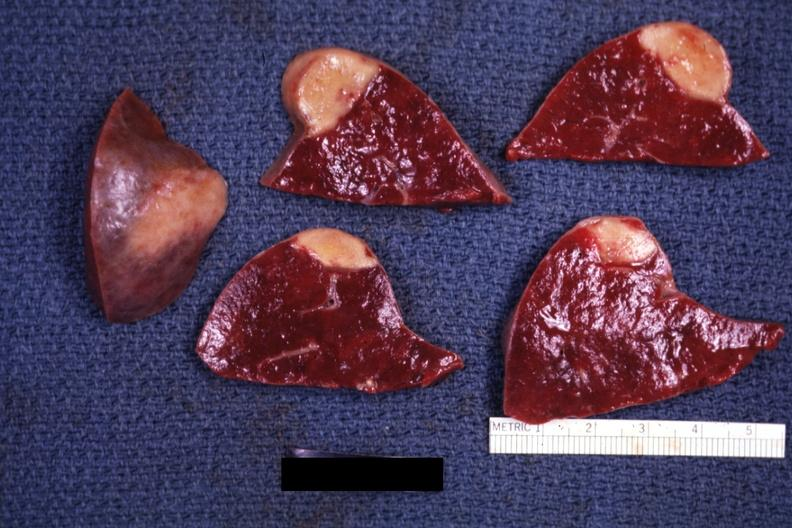what is present?
Answer the question using a single word or phrase. Hematologic 